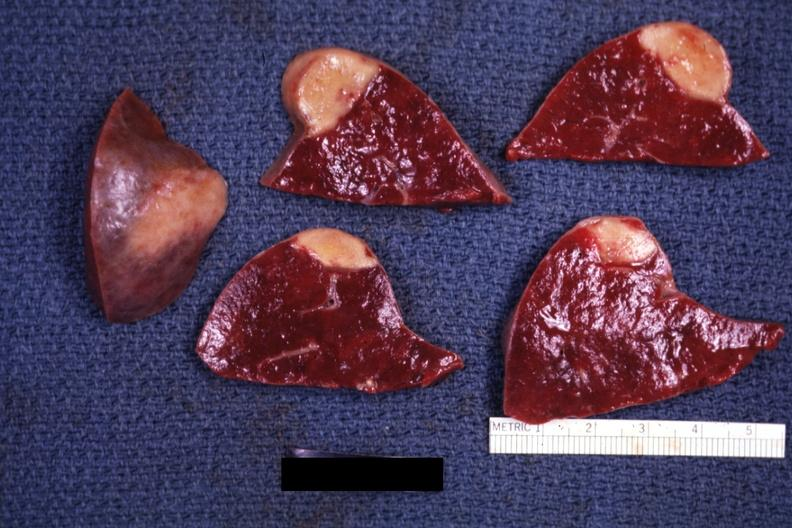what is present?
Answer the question using a single word or phrase. Hematologic 